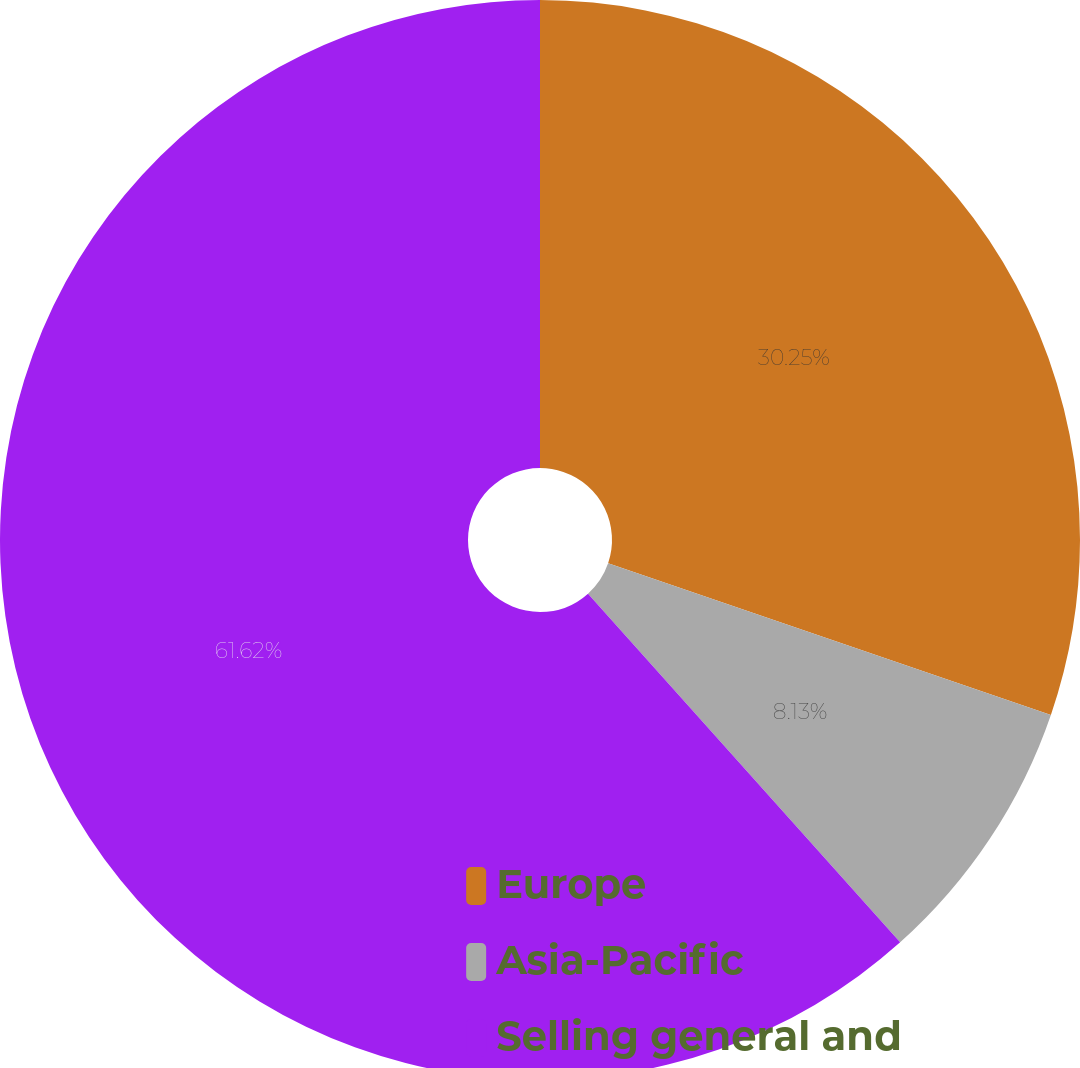Convert chart to OTSL. <chart><loc_0><loc_0><loc_500><loc_500><pie_chart><fcel>Europe<fcel>Asia-Pacific<fcel>Selling general and<nl><fcel>30.25%<fcel>8.13%<fcel>61.62%<nl></chart> 